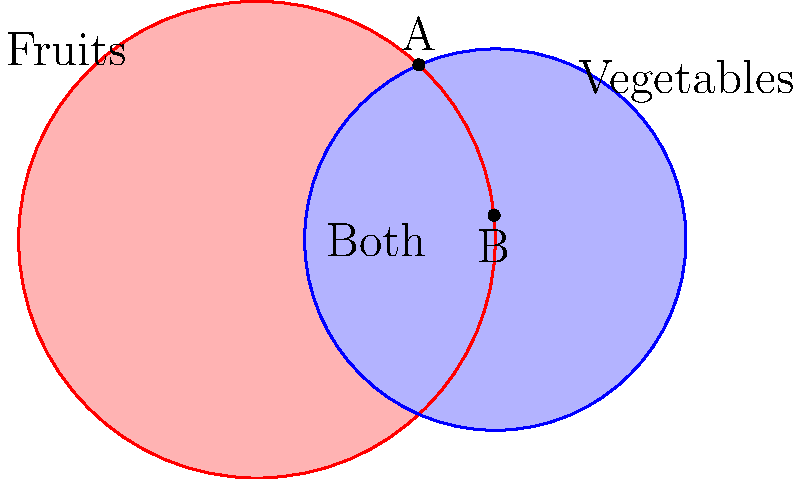A retail expert has provided you with a Venn diagram showing customer preferences for fruits and vegetables. The circle representing fruits has a radius of 15 cm, while the circle for vegetables has a radius of 12 cm. The centers of the circles are 15 cm apart. Calculate the area of the region where the circles overlap, representing customers who prefer both fruits and vegetables. Round your answer to the nearest square centimeter. Let's approach this step-by-step:

1) First, we need to find the angle at the center of each circle formed by the line joining the centers and the line to the point of intersection.

   For the fruit circle (radius 15 cm):
   $$\cos \theta_1 = \frac{15}{2 \times 15} = \frac{1}{2}$$
   $$\theta_1 = \arccos(\frac{1}{2}) = 60°$$

   For the vegetable circle (radius 12 cm):
   $$\cos \theta_2 = \frac{15}{2 \times 12} = \frac{5}{8}$$
   $$\theta_2 = \arccos(\frac{5}{8}) = 51.32°$$

2) Now, we can calculate the area of each sector:

   Fruit sector: $$A_1 = \frac{60}{360} \times \pi \times 15^2 = 39.27 \text{ cm}^2$$
   Vegetable sector: $$A_2 = \frac{51.32}{360} \times \pi \times 12^2 = 19.55 \text{ cm}^2$$

3) Next, we calculate the area of the triangles:

   Fruit triangle: $$T_1 = \frac{1}{2} \times 15 \times 15 \times \sin(60°) = 48.73 \text{ cm}^2$$
   Vegetable triangle: $$T_2 = \frac{1}{2} \times 12 \times 15 \times \sin(51.32°) = 35.07 \text{ cm}^2$$

4) The overlapping area is the sum of the sectors minus the sum of the triangles:

   $$(39.27 + 19.55) - (48.73 + 35.07) = 58.82 - 83.80 = -24.98 \text{ cm}^2$$

5) The negative sign indicates we subtracted too much. The actual overlapping area is:

   $$24.98 \text{ cm}^2$$

6) Rounding to the nearest square centimeter:

   $$25 \text{ cm}^2$$
Answer: 25 cm² 